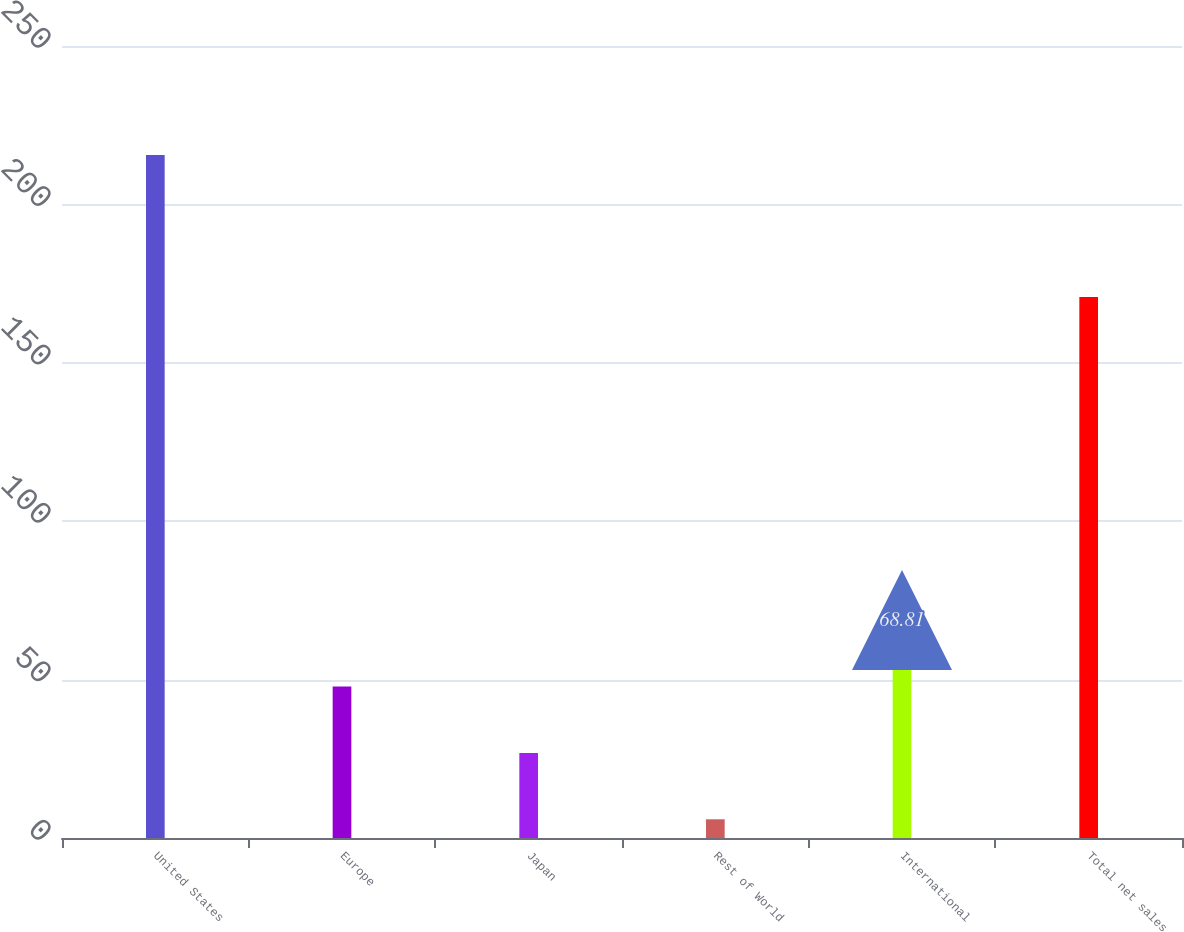<chart> <loc_0><loc_0><loc_500><loc_500><bar_chart><fcel>United States<fcel>Europe<fcel>Japan<fcel>Rest of World<fcel>International<fcel>Total net sales<nl><fcel>215.6<fcel>47.84<fcel>26.87<fcel>5.9<fcel>68.81<fcel>170.8<nl></chart> 